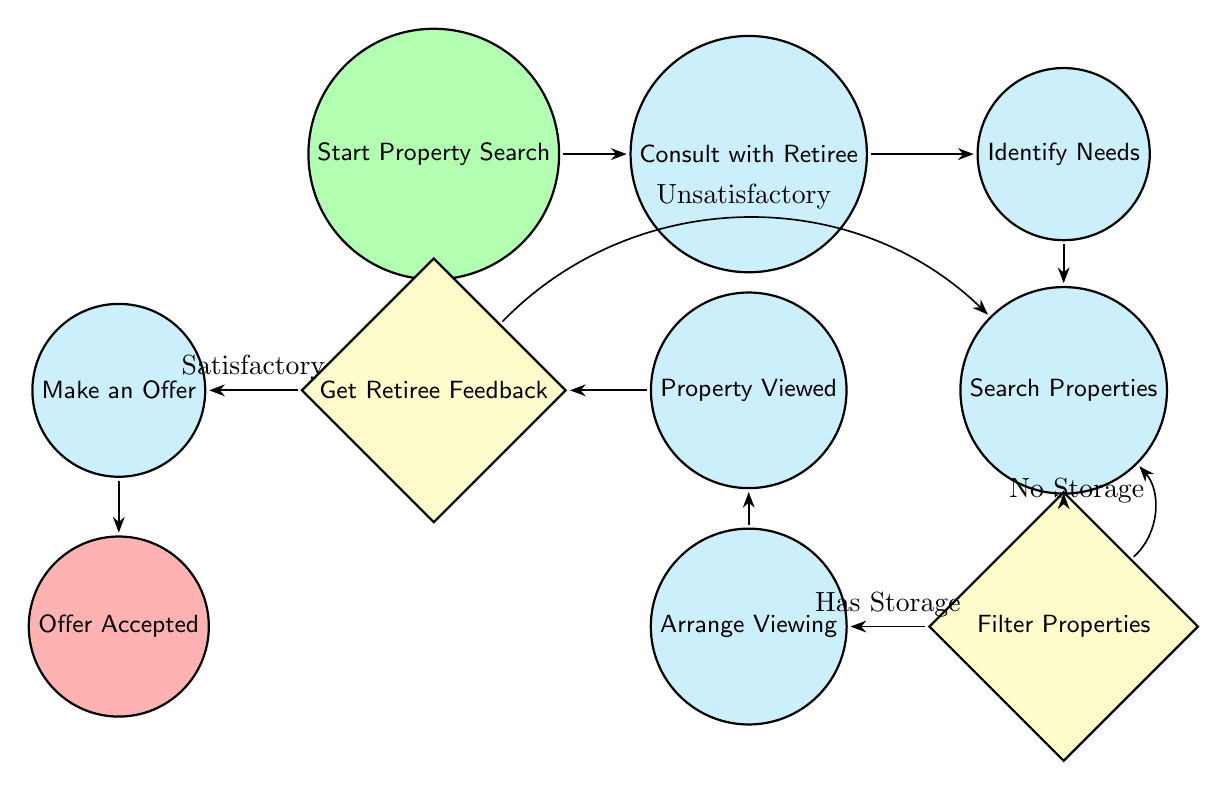What's the starting point of the process? The diagram indicates that the process begins with the "Start Property Search" node, which is marked as the starting state.
Answer: Start Property Search How many decision nodes are present in the diagram? There are two decision nodes in the diagram: "Filter Properties with Storage Spaces" and "Get Retiree Feedback."
Answer: 2 What happens if the retiree feedback is unsatisfactory? According to the diagram, if the retiree feedback is unsatisfactory, the process flows back to "Search Properties."
Answer: Search Properties What is the final step in the property search process? The diagram shows that the final step is "Offer Accepted," which is the end state of the process.
Answer: Offer Accepted What does the "Filter Properties with Storage Spaces" decision node check for? This decision node checks if the properties have suitable storage. Depending on the outcome, it leads to either "Arrange Property Viewing" or loops back to "Search Properties."
Answer: Has Suitable Storage If a property has suitable storage, what is the next process? If a property is found to have suitable storage, the next process is to "Arrange Property Viewing."
Answer: Arrange Property Viewing What node follows “Property Viewed”? Following "Property Viewed," the next node is "Get Retiree Feedback."
Answer: Get Retiree Feedback What is the relationship between the "Identify Needs and Preferences" and "Search Properties" nodes? The "Identify Needs and Preferences" node feeds directly into the "Search Properties" node, indicating that identifying needs is a prerequisite for searching.
Answer: Direct connection 